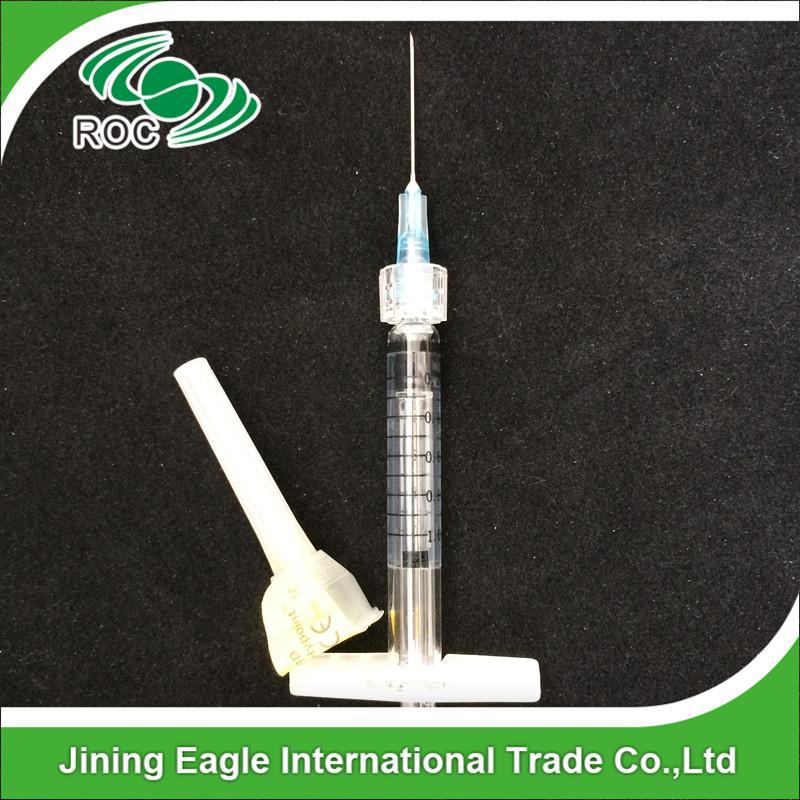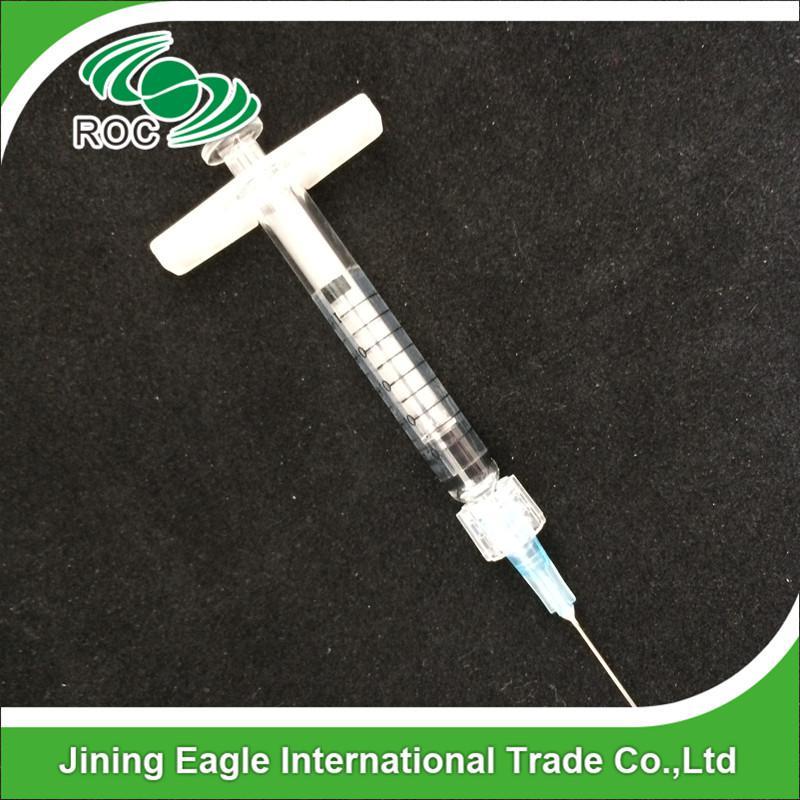The first image is the image on the left, the second image is the image on the right. Given the left and right images, does the statement "The left image shows a single syringe with needle attached." hold true? Answer yes or no. Yes. The first image is the image on the left, the second image is the image on the right. For the images displayed, is the sentence "At least one syringe needle is uncapped." factually correct? Answer yes or no. Yes. 